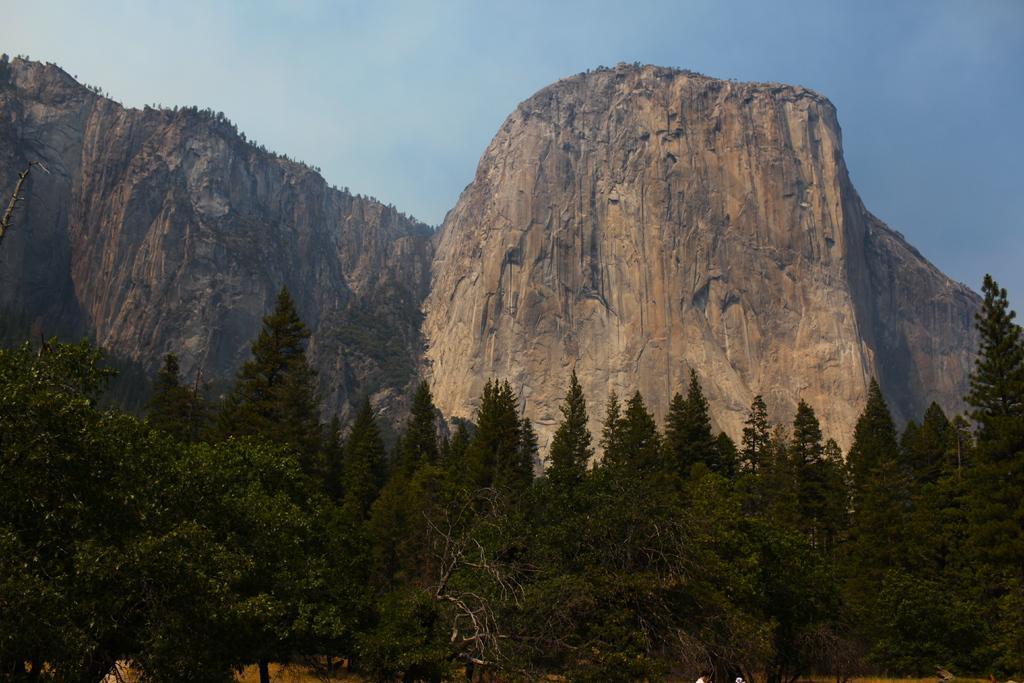Could you give a brief overview of what you see in this image? In the image there are trees in the front, followed by mountains over the back and above its sky. 